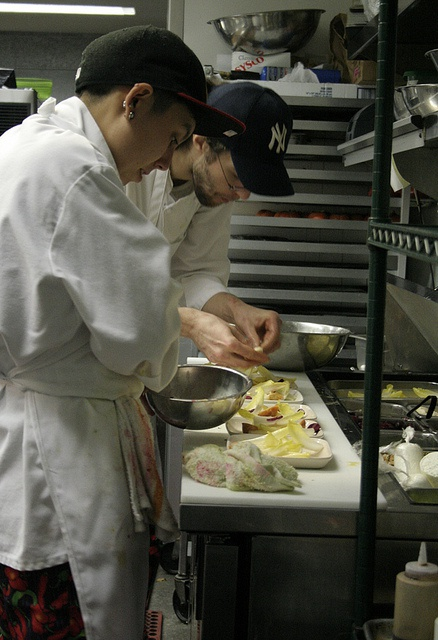Describe the objects in this image and their specific colors. I can see people in gray, black, darkgray, and lightgray tones, oven in gray, black, darkgray, and darkgreen tones, people in gray and black tones, bowl in gray, black, darkgreen, and olive tones, and bottle in gray, black, and darkgreen tones in this image. 